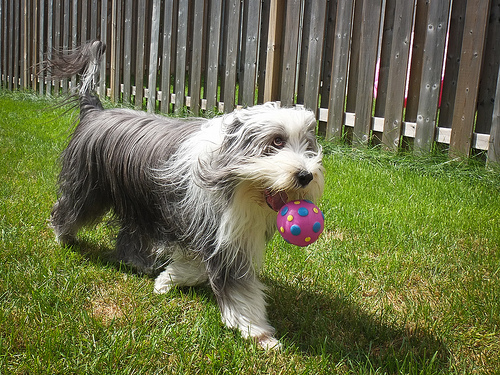<image>
Is there a dog behind the ball? Yes. From this viewpoint, the dog is positioned behind the ball, with the ball partially or fully occluding the dog. 